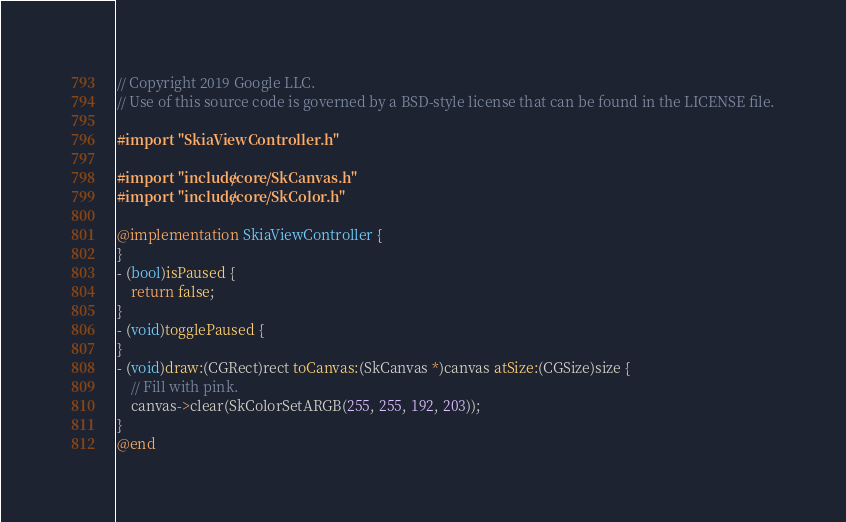<code> <loc_0><loc_0><loc_500><loc_500><_ObjectiveC_>// Copyright 2019 Google LLC.
// Use of this source code is governed by a BSD-style license that can be found in the LICENSE file.

#import "SkiaViewController.h"

#import "include/core/SkCanvas.h"
#import "include/core/SkColor.h"

@implementation SkiaViewController {
}
- (bool)isPaused {
	return false;
}
- (void)togglePaused {
}
- (void)draw:(CGRect)rect toCanvas:(SkCanvas *)canvas atSize:(CGSize)size {
	// Fill with pink.
	canvas->clear(SkColorSetARGB(255, 255, 192, 203));
}
@end

</code> 